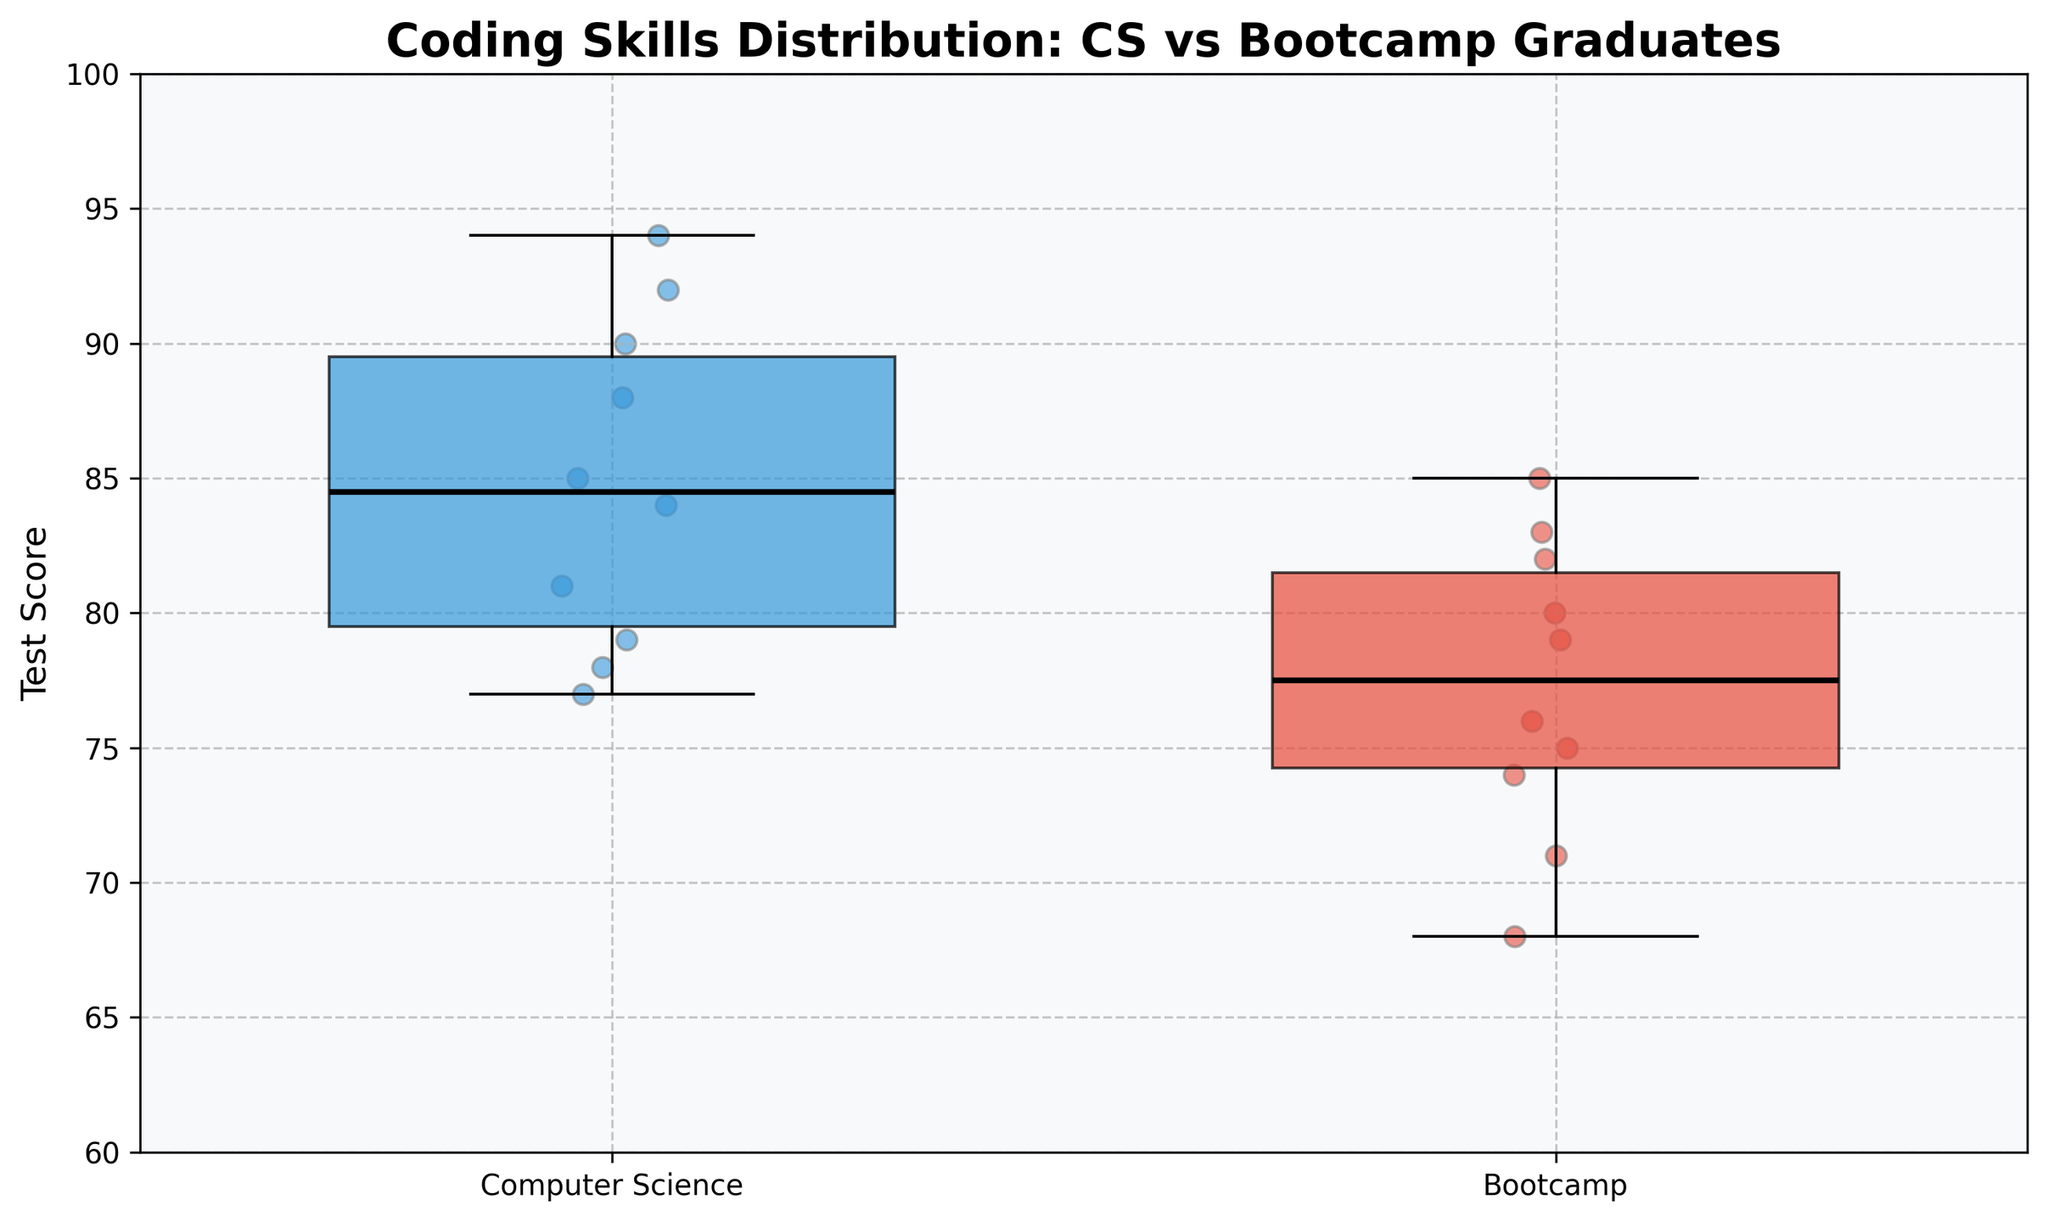What is the title of the chart? The title of the chart is displayed at the top of the figure. It provides a summary of what the chart is about. In this case, it states the distribution of coding skills between the two groups being compared, namely Computer Science graduates and Bootcamp graduates.
Answer: Coding Skills Distribution: CS vs Bootcamp Graduates What are the groups being compared in the box plot? The box plot compares two groups. This is indicated by the labels on the x-axis. The first group is labeled "Computer Science" and the second group is labeled "Bootcamp".
Answer: Computer Science and Bootcamp Which group has a higher median test score? To find the median test score, refer to the line inside each box in the box plot. The box with the higher median line indicates the group with the higher median score. The median line for Computer Science is higher than that for Bootcamp.
Answer: Computer Science What are the test score ranges for Computer Science and Bootcamp graduates? The test score range for each group can be determined by looking at the whiskers of each box plot. The whiskers extend to the minimum and maximum data points within 1.5 IQR of the lower and upper quartiles. For Computer Science, the range is from 77 to 94. For Bootcamp, the range is from 68 to 85.
Answer: Computer Science: 77-94, Bootcamp: 68-85 How does the interquartile range (IQR) of the Computer Science graduates compare to the IQR of the Bootcamp graduates? The IQR is the range between the first and third quartiles (the bottom and top of the box). For Computer Science, the IQR is the distance from the 25th percentile to the 75th percentile. The same calculation applies to Bootcamp. Visually, the IQR for Computer Science looks larger than that for Bootcamp.
Answer: Computer Science has a larger IQR Which group shows more variability in test scores? The variability in test scores can be assessed by looking at the length of the whiskers and the spread of the individual data points. The group with the larger range and more scattered points shows more variability. In this case, Bootcamp graduates show wider spread in scores from the median.
Answer: Bootcamp Are there any outliers in the data? If so, in which group(s)? Outliers are usually represented by individual points that fall outside the whiskers of the box plot. By examining the plot, we can see if there are any isolated points far from the box plot whiskers. There are no explicit outliers shown in either group.
Answer: No outliers What is the highest test score observed for Bootcamp graduates? The highest test score is represented by the top whisker of the Bootcamp box plot. This whisker extends up to the maximum test score.
Answer: 85 Comparing the two groups, which group appears more consistent in their test scores? Consistency of test scores can be inferred from the compactness of the box plot. A more compact box plot indicates less variability. The Computer Science group has a more compact box plot indicating more consistency.
Answer: Computer Science What's the median test score for each group? The median is indicated by the line inside each box. For Computer Science, the line representing the median score is around 85. For Bootcamp, the line representing the median score is around 77.
Answer: Computer Science: 85, Bootcamp: 77 